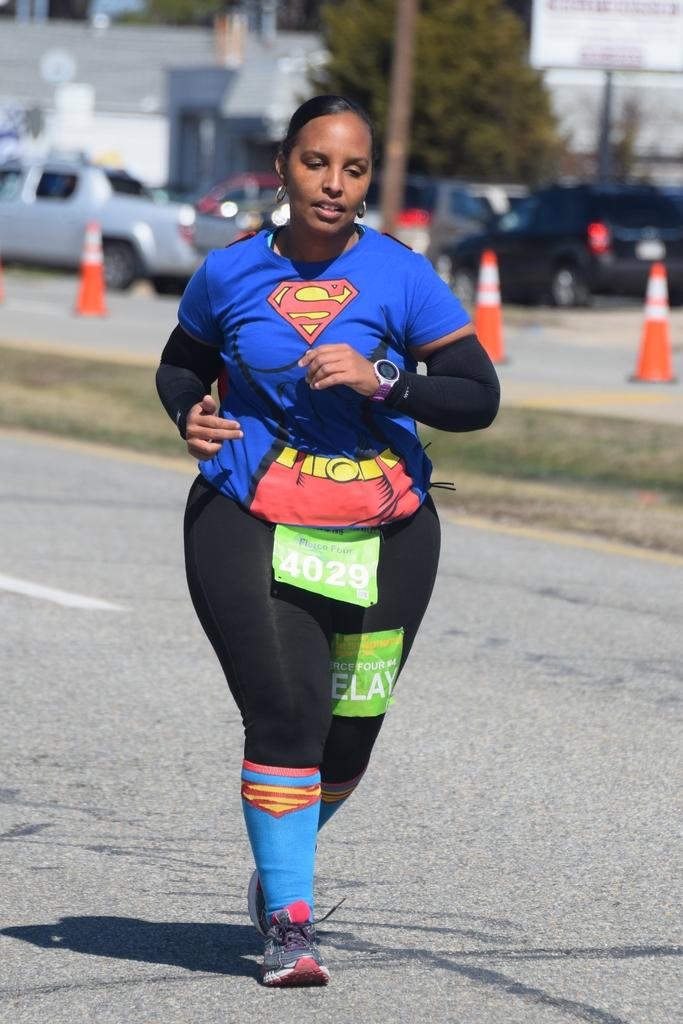Who is the main subject in the image? There is a woman in the image. What is the woman wearing? The woman is wearing a blue dress. What is the woman doing in the image? The woman is running in the front of the image. What can be seen in the background of the image? There are traffic cones, vehicles, trees, a fence, and a building in the background of the image. What effect does the woman's running have on the trees in the image? The woman's running does not have any effect on the trees in the image, as they are separate elements in the background. 